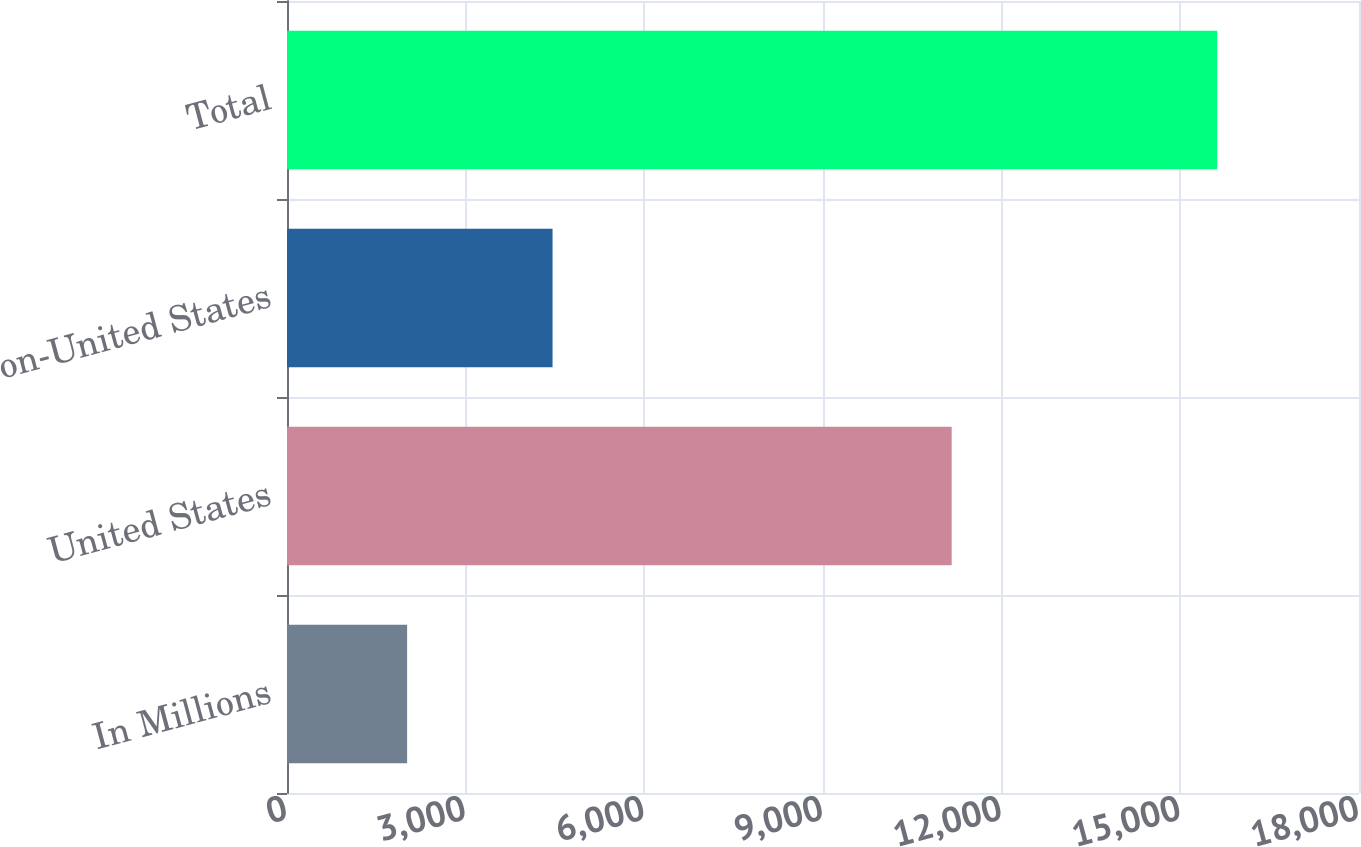Convert chart. <chart><loc_0><loc_0><loc_500><loc_500><bar_chart><fcel>In Millions<fcel>United States<fcel>Non-United States<fcel>Total<nl><fcel>2017<fcel>11160.9<fcel>4458.9<fcel>15619.8<nl></chart> 